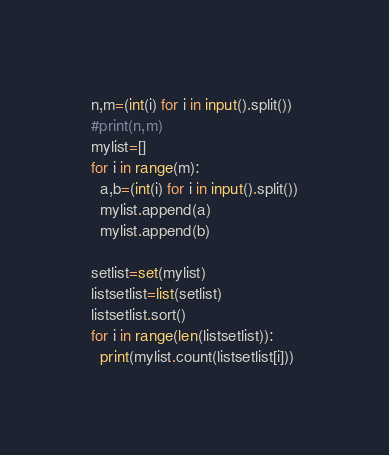<code> <loc_0><loc_0><loc_500><loc_500><_Python_>n,m=(int(i) for i in input().split())
#print(n,m)
mylist=[]
for i in range(m):
  a,b=(int(i) for i in input().split())
  mylist.append(a)
  mylist.append(b)
  
setlist=set(mylist)
listsetlist=list(setlist)
listsetlist.sort()
for i in range(len(listsetlist)):
  print(mylist.count(listsetlist[i]))</code> 